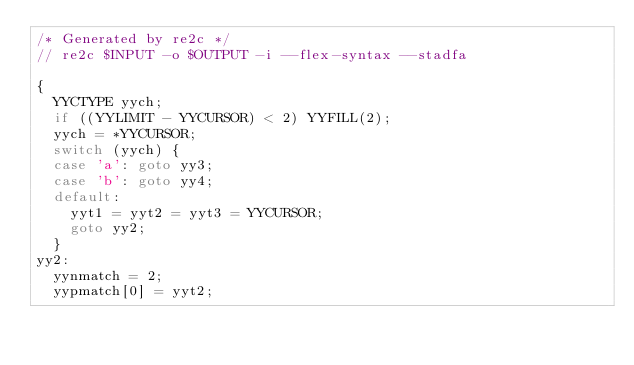<code> <loc_0><loc_0><loc_500><loc_500><_C_>/* Generated by re2c */
// re2c $INPUT -o $OUTPUT -i --flex-syntax --stadfa

{
	YYCTYPE yych;
	if ((YYLIMIT - YYCURSOR) < 2) YYFILL(2);
	yych = *YYCURSOR;
	switch (yych) {
	case 'a':	goto yy3;
	case 'b':	goto yy4;
	default:
		yyt1 = yyt2 = yyt3 = YYCURSOR;
		goto yy2;
	}
yy2:
	yynmatch = 2;
	yypmatch[0] = yyt2;</code> 